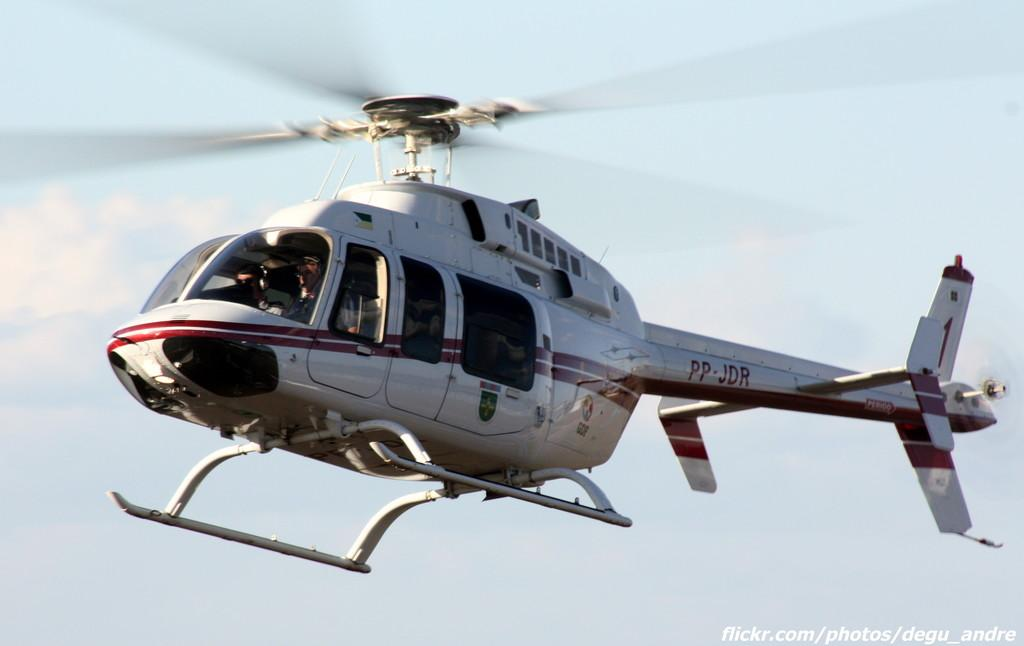<image>
Present a compact description of the photo's key features. A red and white helicopter has the letters PP-JDR on it in red. 